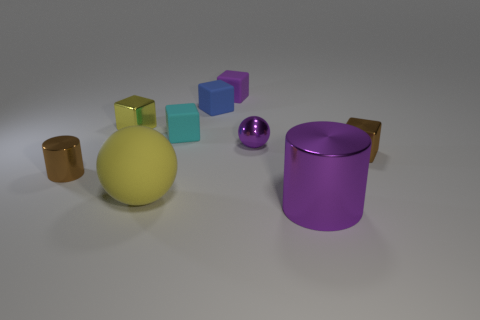Subtract all small cyan matte blocks. How many blocks are left? 4 Subtract all purple cubes. How many cubes are left? 4 Add 1 purple shiny cylinders. How many objects exist? 10 Subtract 3 cubes. How many cubes are left? 2 Subtract all yellow cubes. Subtract all purple balls. How many cubes are left? 4 Subtract 1 brown cylinders. How many objects are left? 8 Subtract all spheres. How many objects are left? 7 Subtract all small shiny spheres. Subtract all purple shiny spheres. How many objects are left? 7 Add 3 large things. How many large things are left? 5 Add 3 shiny objects. How many shiny objects exist? 8 